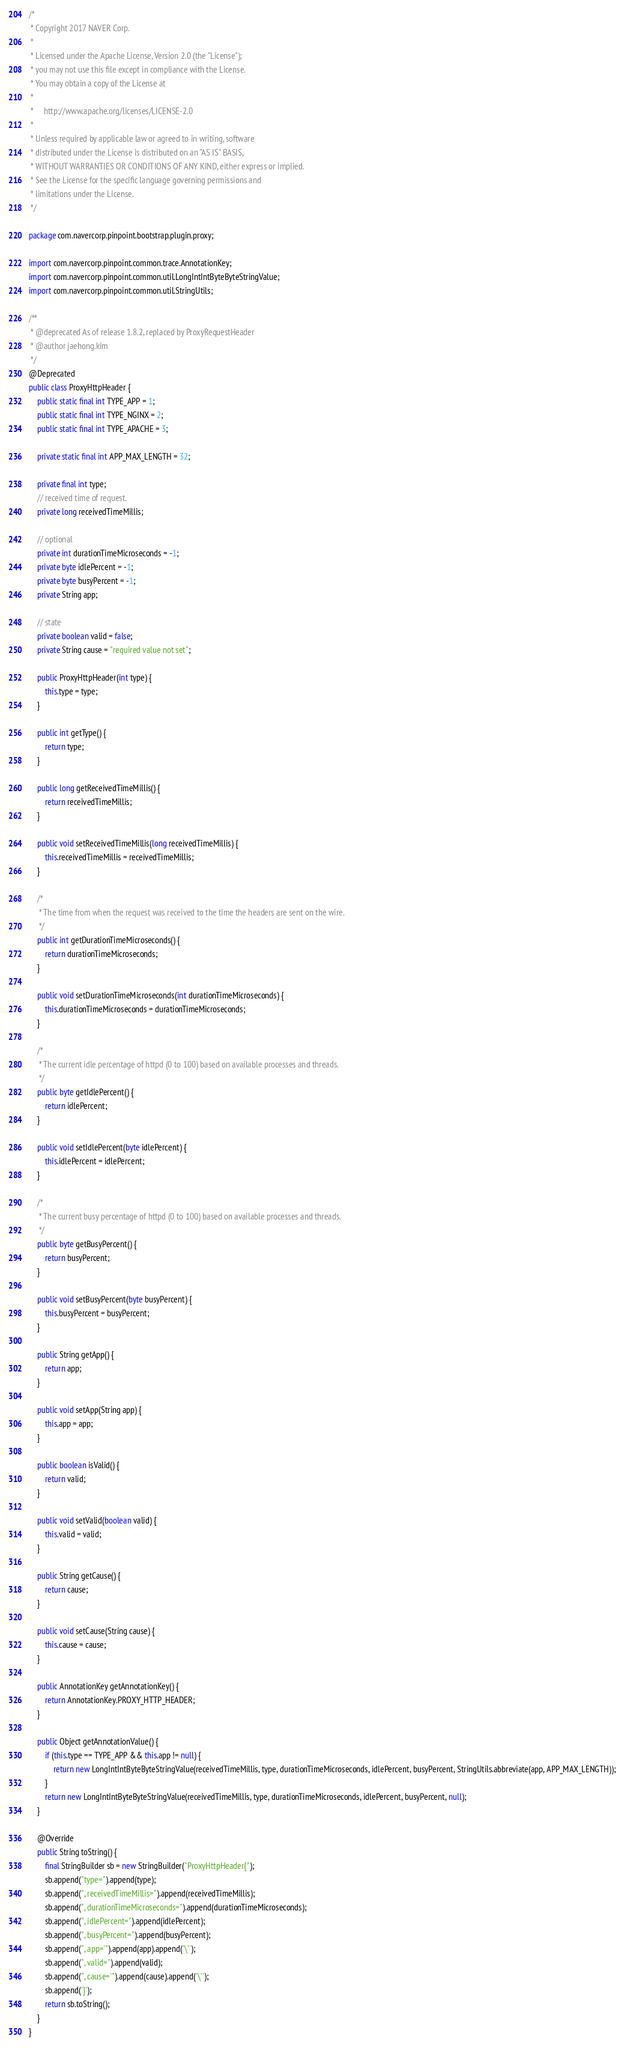<code> <loc_0><loc_0><loc_500><loc_500><_Java_>/*
 * Copyright 2017 NAVER Corp.
 *
 * Licensed under the Apache License, Version 2.0 (the "License");
 * you may not use this file except in compliance with the License.
 * You may obtain a copy of the License at
 *
 *     http://www.apache.org/licenses/LICENSE-2.0
 *
 * Unless required by applicable law or agreed to in writing, software
 * distributed under the License is distributed on an "AS IS" BASIS,
 * WITHOUT WARRANTIES OR CONDITIONS OF ANY KIND, either express or implied.
 * See the License for the specific language governing permissions and
 * limitations under the License.
 */

package com.navercorp.pinpoint.bootstrap.plugin.proxy;

import com.navercorp.pinpoint.common.trace.AnnotationKey;
import com.navercorp.pinpoint.common.util.LongIntIntByteByteStringValue;
import com.navercorp.pinpoint.common.util.StringUtils;

/**
 * @deprecated As of release 1.8.2, replaced by ProxyRequestHeader
 * @author jaehong.kim
 */
@Deprecated
public class ProxyHttpHeader {
    public static final int TYPE_APP = 1;
    public static final int TYPE_NGINX = 2;
    public static final int TYPE_APACHE = 3;

    private static final int APP_MAX_LENGTH = 32;

    private final int type;
    // received time of request.
    private long receivedTimeMillis;

    // optional
    private int durationTimeMicroseconds = -1;
    private byte idlePercent = -1;
    private byte busyPercent = -1;
    private String app;

    // state
    private boolean valid = false;
    private String cause = "required value not set";

    public ProxyHttpHeader(int type) {
        this.type = type;
    }

    public int getType() {
        return type;
    }

    public long getReceivedTimeMillis() {
        return receivedTimeMillis;
    }

    public void setReceivedTimeMillis(long receivedTimeMillis) {
        this.receivedTimeMillis = receivedTimeMillis;
    }

    /*
     * The time from when the request was received to the time the headers are sent on the wire.
     */
    public int getDurationTimeMicroseconds() {
        return durationTimeMicroseconds;
    }

    public void setDurationTimeMicroseconds(int durationTimeMicroseconds) {
        this.durationTimeMicroseconds = durationTimeMicroseconds;
    }

    /*
     * The current idle percentage of httpd (0 to 100) based on available processes and threads.
     */
    public byte getIdlePercent() {
        return idlePercent;
    }

    public void setIdlePercent(byte idlePercent) {
        this.idlePercent = idlePercent;
    }

    /*
     * The current busy percentage of httpd (0 to 100) based on available processes and threads.
     */
    public byte getBusyPercent() {
        return busyPercent;
    }

    public void setBusyPercent(byte busyPercent) {
        this.busyPercent = busyPercent;
    }

    public String getApp() {
        return app;
    }

    public void setApp(String app) {
        this.app = app;
    }

    public boolean isValid() {
        return valid;
    }

    public void setValid(boolean valid) {
        this.valid = valid;
    }

    public String getCause() {
        return cause;
    }

    public void setCause(String cause) {
        this.cause = cause;
    }

    public AnnotationKey getAnnotationKey() {
        return AnnotationKey.PROXY_HTTP_HEADER;
    }

    public Object getAnnotationValue() {
        if (this.type == TYPE_APP && this.app != null) {
            return new LongIntIntByteByteStringValue(receivedTimeMillis, type, durationTimeMicroseconds, idlePercent, busyPercent, StringUtils.abbreviate(app, APP_MAX_LENGTH));
        }
        return new LongIntIntByteByteStringValue(receivedTimeMillis, type, durationTimeMicroseconds, idlePercent, busyPercent, null);
    }

    @Override
    public String toString() {
        final StringBuilder sb = new StringBuilder("ProxyHttpHeader{");
        sb.append("type=").append(type);
        sb.append(", receivedTimeMillis=").append(receivedTimeMillis);
        sb.append(", durationTimeMicroseconds=").append(durationTimeMicroseconds);
        sb.append(", idlePercent=").append(idlePercent);
        sb.append(", busyPercent=").append(busyPercent);
        sb.append(", app='").append(app).append('\'');
        sb.append(", valid=").append(valid);
        sb.append(", cause='").append(cause).append('\'');
        sb.append('}');
        return sb.toString();
    }
}</code> 